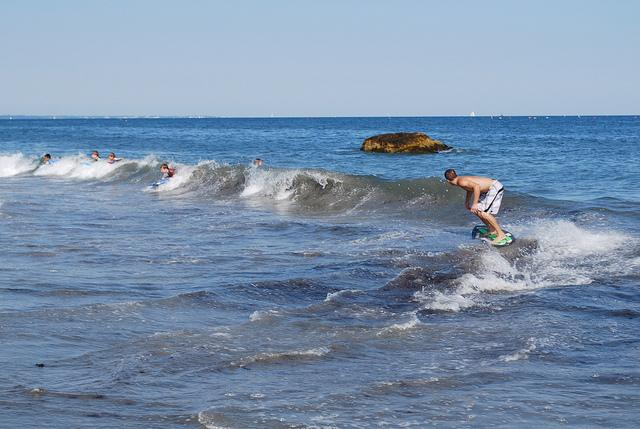Who is the most famous surfer? kelly slater 